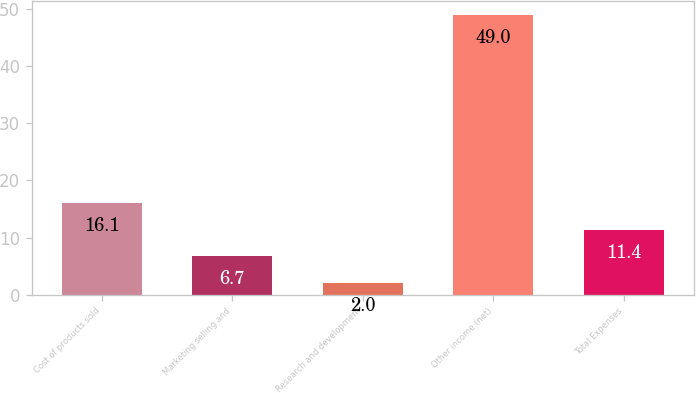<chart> <loc_0><loc_0><loc_500><loc_500><bar_chart><fcel>Cost of products sold<fcel>Marketing selling and<fcel>Research and development<fcel>Other income (net)<fcel>Total Expenses<nl><fcel>16.1<fcel>6.7<fcel>2<fcel>49<fcel>11.4<nl></chart> 